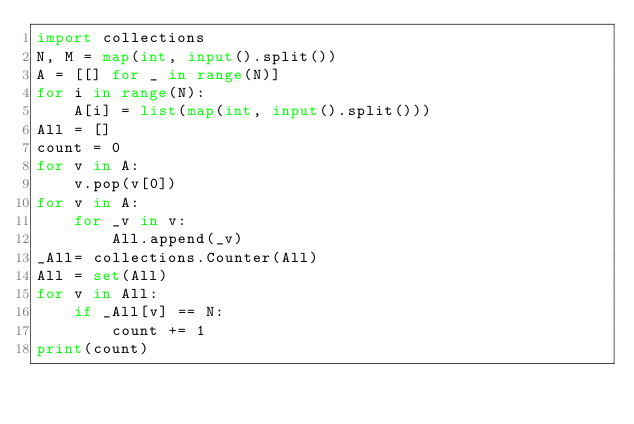<code> <loc_0><loc_0><loc_500><loc_500><_Python_>import collections
N, M = map(int, input().split())
A = [[] for _ in range(N)]
for i in range(N):
    A[i] = list(map(int, input().split()))
All = []
count = 0
for v in A:
    v.pop(v[0])
for v in A:
    for _v in v:
        All.append(_v)
_All= collections.Counter(All)
All = set(All)
for v in All:
    if _All[v] == N:
        count += 1
print(count)</code> 